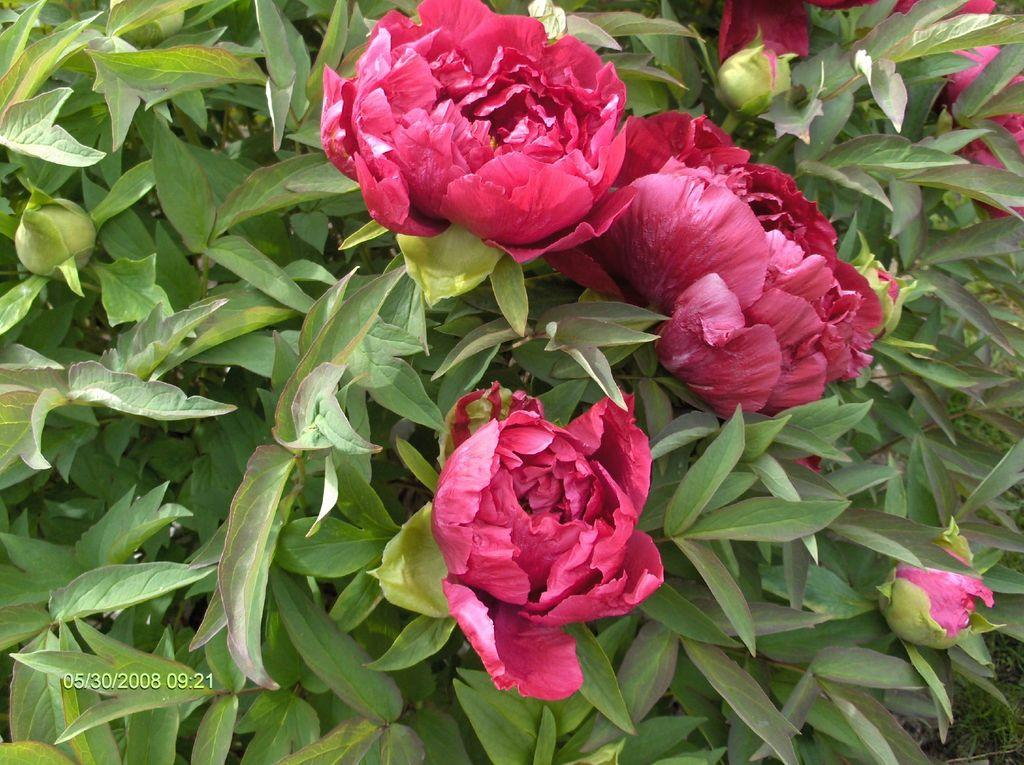What color are the flowers in the image? The flowers in the image are red. What color are the leaves in the image? The leaves in the image are green. What stage of growth are some of the plants in the image? There are buds in the image, which are a stage of growth before flowers bloom. How many eyes does the mother have in the image? There is no mother or eyes present in the image; it features red flowers, green leaves, and buds. 